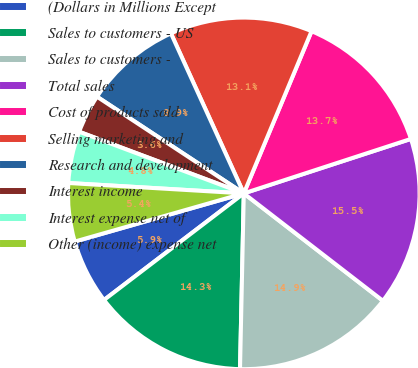Convert chart to OTSL. <chart><loc_0><loc_0><loc_500><loc_500><pie_chart><fcel>(Dollars in Millions Except<fcel>Sales to customers - US<fcel>Sales to customers -<fcel>Total sales<fcel>Cost of products sold<fcel>Selling marketing and<fcel>Research and development<fcel>Interest income<fcel>Interest expense net of<fcel>Other (income) expense net<nl><fcel>5.95%<fcel>14.29%<fcel>14.88%<fcel>15.48%<fcel>13.69%<fcel>13.1%<fcel>8.93%<fcel>3.57%<fcel>4.76%<fcel>5.36%<nl></chart> 